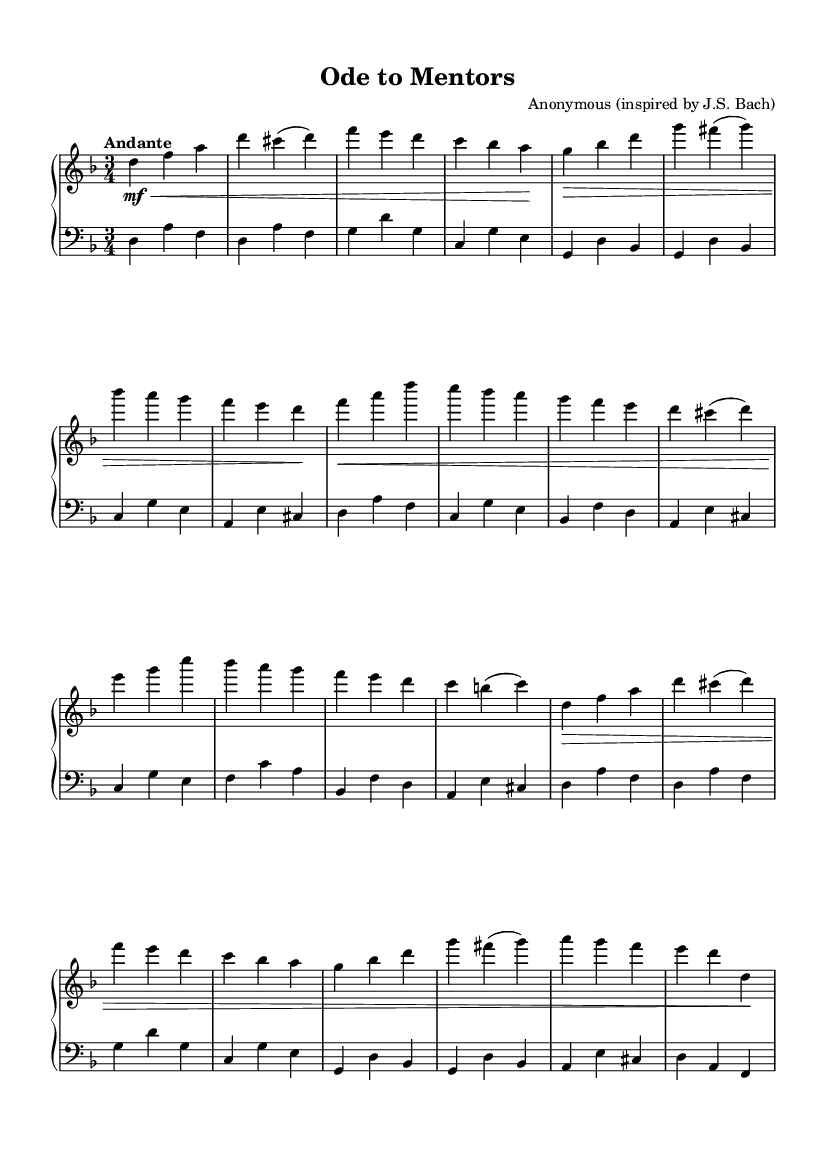What is the time signature of this music? The time signature is indicated at the beginning of the score, showing three beats per measure. This is represented as a fraction with a three on top and a four on the bottom.
Answer: 3/4 What is the key signature of this music? The key signature can be found at the beginning of the score, showing one flat. This indicates that the piece is in the key of D minor.
Answer: D minor What is the tempo marking for this piece? The tempo marking is shown explicitly above the staff, stating the speed of the music. It is indicated as "Andante".
Answer: Andante How many sections are present in the piece? By analyzing the format of the score, it is observed that there are three distinct sections labeled A, B, and A'. The repetition of section A indicates it has a variation.
Answer: 3 What instruments are indicated for this composition? The score indicates the music is written for the piano, as shown by the staff designation "PianoStaff" at the beginning.
Answer: Piano Which section contains the phrase starting with "g bes d"? By examining the labeled sections in the score, the phrase starting with "g bes d" can be located in section A' as it closely correlates with the repetition of earlier themes.
Answer: A' What is the overall style of this composition? Considering the elements in the score such as the ornamentation, phrasing, and structure, it can be concluded that this piece is written in the Baroque style.
Answer: Baroque 